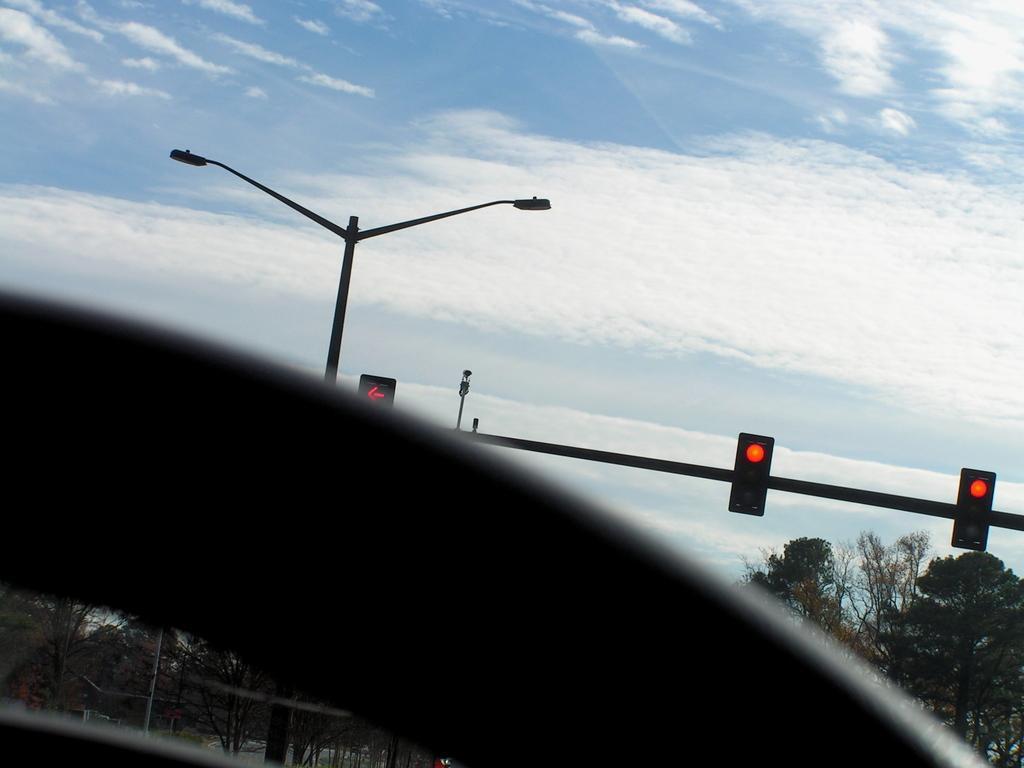How would you summarize this image in a sentence or two? At the bottom we can see an object. In the background there are traffic signal poles, trees, street lights, poles and clouds in the sky. 